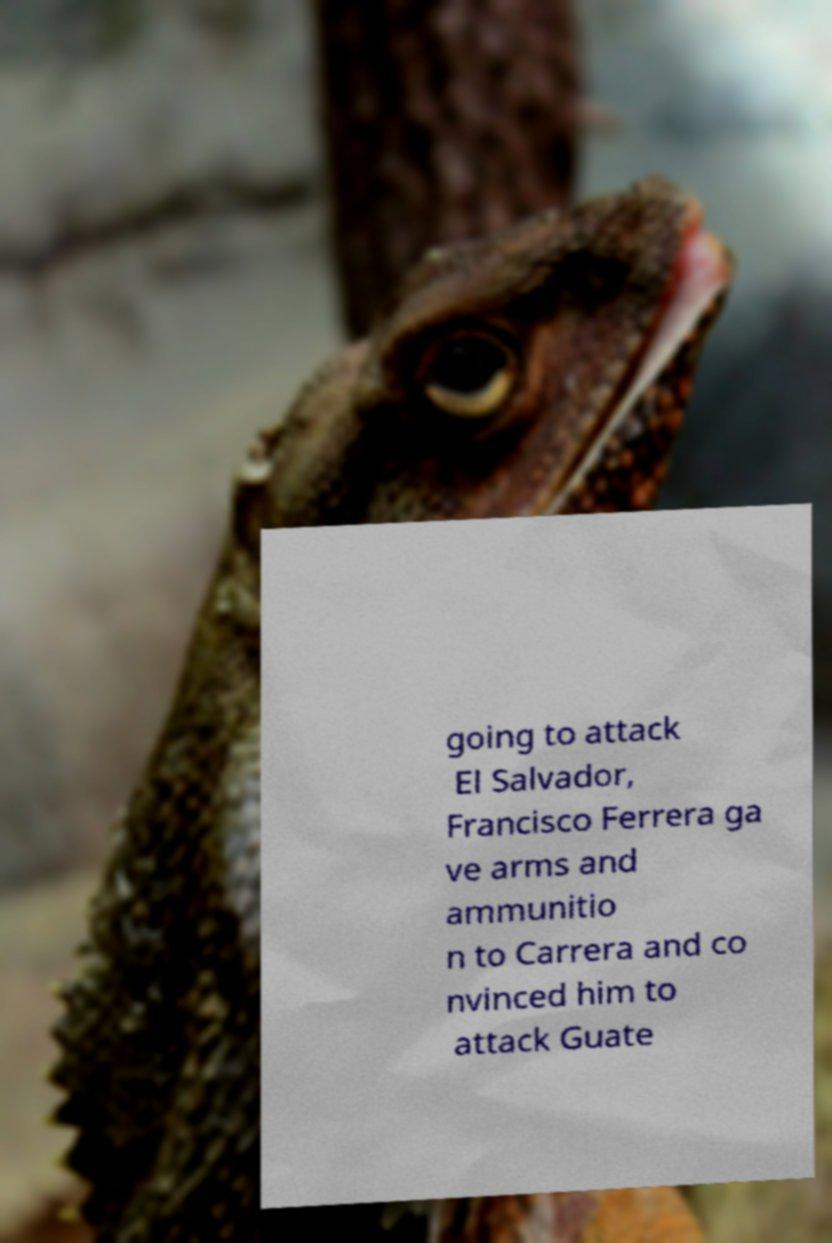Can you read and provide the text displayed in the image?This photo seems to have some interesting text. Can you extract and type it out for me? going to attack El Salvador, Francisco Ferrera ga ve arms and ammunitio n to Carrera and co nvinced him to attack Guate 